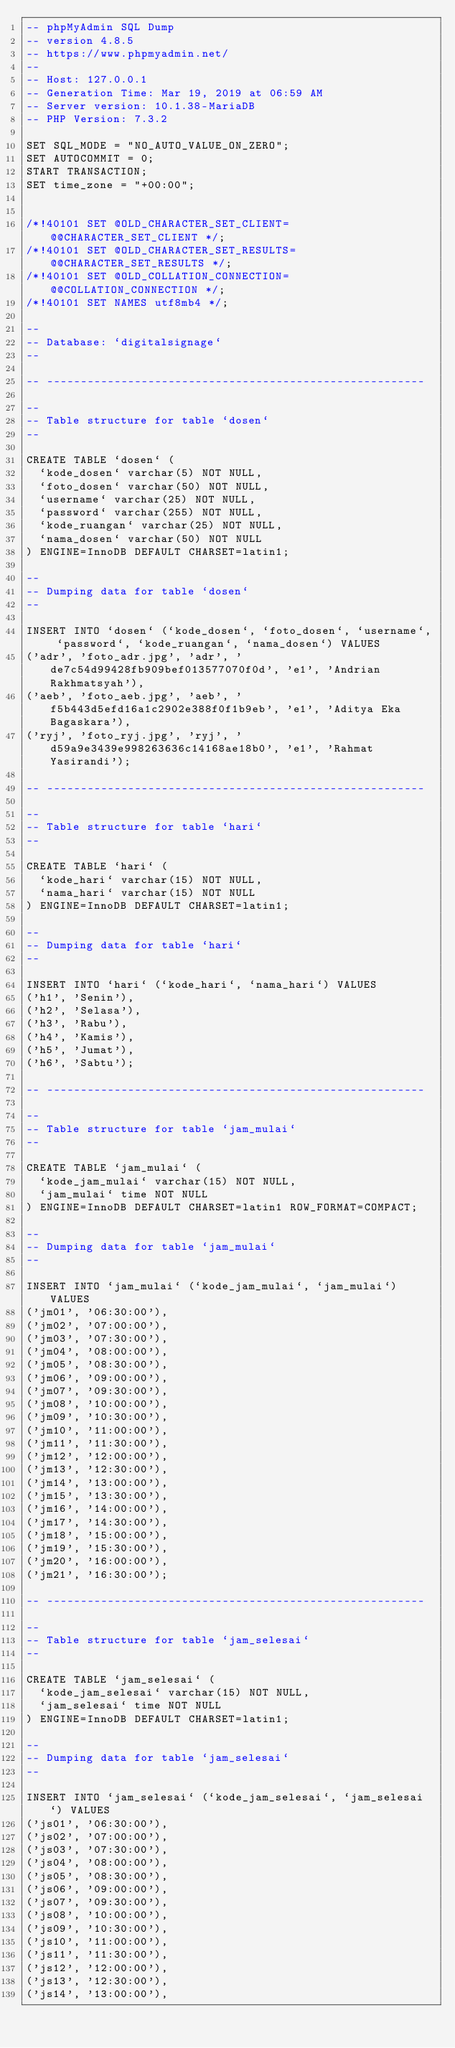<code> <loc_0><loc_0><loc_500><loc_500><_SQL_>-- phpMyAdmin SQL Dump
-- version 4.8.5
-- https://www.phpmyadmin.net/
--
-- Host: 127.0.0.1
-- Generation Time: Mar 19, 2019 at 06:59 AM
-- Server version: 10.1.38-MariaDB
-- PHP Version: 7.3.2

SET SQL_MODE = "NO_AUTO_VALUE_ON_ZERO";
SET AUTOCOMMIT = 0;
START TRANSACTION;
SET time_zone = "+00:00";


/*!40101 SET @OLD_CHARACTER_SET_CLIENT=@@CHARACTER_SET_CLIENT */;
/*!40101 SET @OLD_CHARACTER_SET_RESULTS=@@CHARACTER_SET_RESULTS */;
/*!40101 SET @OLD_COLLATION_CONNECTION=@@COLLATION_CONNECTION */;
/*!40101 SET NAMES utf8mb4 */;

--
-- Database: `digitalsignage`
--

-- --------------------------------------------------------

--
-- Table structure for table `dosen`
--

CREATE TABLE `dosen` (
  `kode_dosen` varchar(5) NOT NULL,
  `foto_dosen` varchar(50) NOT NULL,
  `username` varchar(25) NOT NULL,
  `password` varchar(255) NOT NULL,
  `kode_ruangan` varchar(25) NOT NULL,
  `nama_dosen` varchar(50) NOT NULL
) ENGINE=InnoDB DEFAULT CHARSET=latin1;

--
-- Dumping data for table `dosen`
--

INSERT INTO `dosen` (`kode_dosen`, `foto_dosen`, `username`, `password`, `kode_ruangan`, `nama_dosen`) VALUES
('adr', 'foto_adr.jpg', 'adr', 'de7c54d99428fb909bef013577070f0d', 'e1', 'Andrian Rakhmatsyah'),
('aeb', 'foto_aeb.jpg', 'aeb', 'f5b443d5efd16a1c2902e388f0f1b9eb', 'e1', 'Aditya Eka Bagaskara'),
('ryj', 'foto_ryj.jpg', 'ryj', 'd59a9e3439e998263636c14168ae18b0', 'e1', 'Rahmat Yasirandi');

-- --------------------------------------------------------

--
-- Table structure for table `hari`
--

CREATE TABLE `hari` (
  `kode_hari` varchar(15) NOT NULL,
  `nama_hari` varchar(15) NOT NULL
) ENGINE=InnoDB DEFAULT CHARSET=latin1;

--
-- Dumping data for table `hari`
--

INSERT INTO `hari` (`kode_hari`, `nama_hari`) VALUES
('h1', 'Senin'),
('h2', 'Selasa'),
('h3', 'Rabu'),
('h4', 'Kamis'),
('h5', 'Jumat'),
('h6', 'Sabtu');

-- --------------------------------------------------------

--
-- Table structure for table `jam_mulai`
--

CREATE TABLE `jam_mulai` (
  `kode_jam_mulai` varchar(15) NOT NULL,
  `jam_mulai` time NOT NULL
) ENGINE=InnoDB DEFAULT CHARSET=latin1 ROW_FORMAT=COMPACT;

--
-- Dumping data for table `jam_mulai`
--

INSERT INTO `jam_mulai` (`kode_jam_mulai`, `jam_mulai`) VALUES
('jm01', '06:30:00'),
('jm02', '07:00:00'),
('jm03', '07:30:00'),
('jm04', '08:00:00'),
('jm05', '08:30:00'),
('jm06', '09:00:00'),
('jm07', '09:30:00'),
('jm08', '10:00:00'),
('jm09', '10:30:00'),
('jm10', '11:00:00'),
('jm11', '11:30:00'),
('jm12', '12:00:00'),
('jm13', '12:30:00'),
('jm14', '13:00:00'),
('jm15', '13:30:00'),
('jm16', '14:00:00'),
('jm17', '14:30:00'),
('jm18', '15:00:00'),
('jm19', '15:30:00'),
('jm20', '16:00:00'),
('jm21', '16:30:00');

-- --------------------------------------------------------

--
-- Table structure for table `jam_selesai`
--

CREATE TABLE `jam_selesai` (
  `kode_jam_selesai` varchar(15) NOT NULL,
  `jam_selesai` time NOT NULL
) ENGINE=InnoDB DEFAULT CHARSET=latin1;

--
-- Dumping data for table `jam_selesai`
--

INSERT INTO `jam_selesai` (`kode_jam_selesai`, `jam_selesai`) VALUES
('js01', '06:30:00'),
('js02', '07:00:00'),
('js03', '07:30:00'),
('js04', '08:00:00'),
('js05', '08:30:00'),
('js06', '09:00:00'),
('js07', '09:30:00'),
('js08', '10:00:00'),
('js09', '10:30:00'),
('js10', '11:00:00'),
('js11', '11:30:00'),
('js12', '12:00:00'),
('js13', '12:30:00'),
('js14', '13:00:00'),</code> 